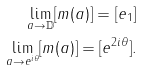<formula> <loc_0><loc_0><loc_500><loc_500>\lim _ { a \rightarrow \mathbb { D } } [ m ( a ) ] = [ e _ { 1 } ] \\ \lim _ { a \rightarrow e ^ { i \theta } } [ m ( a ) ] = [ e ^ { 2 i \theta } ] .</formula> 